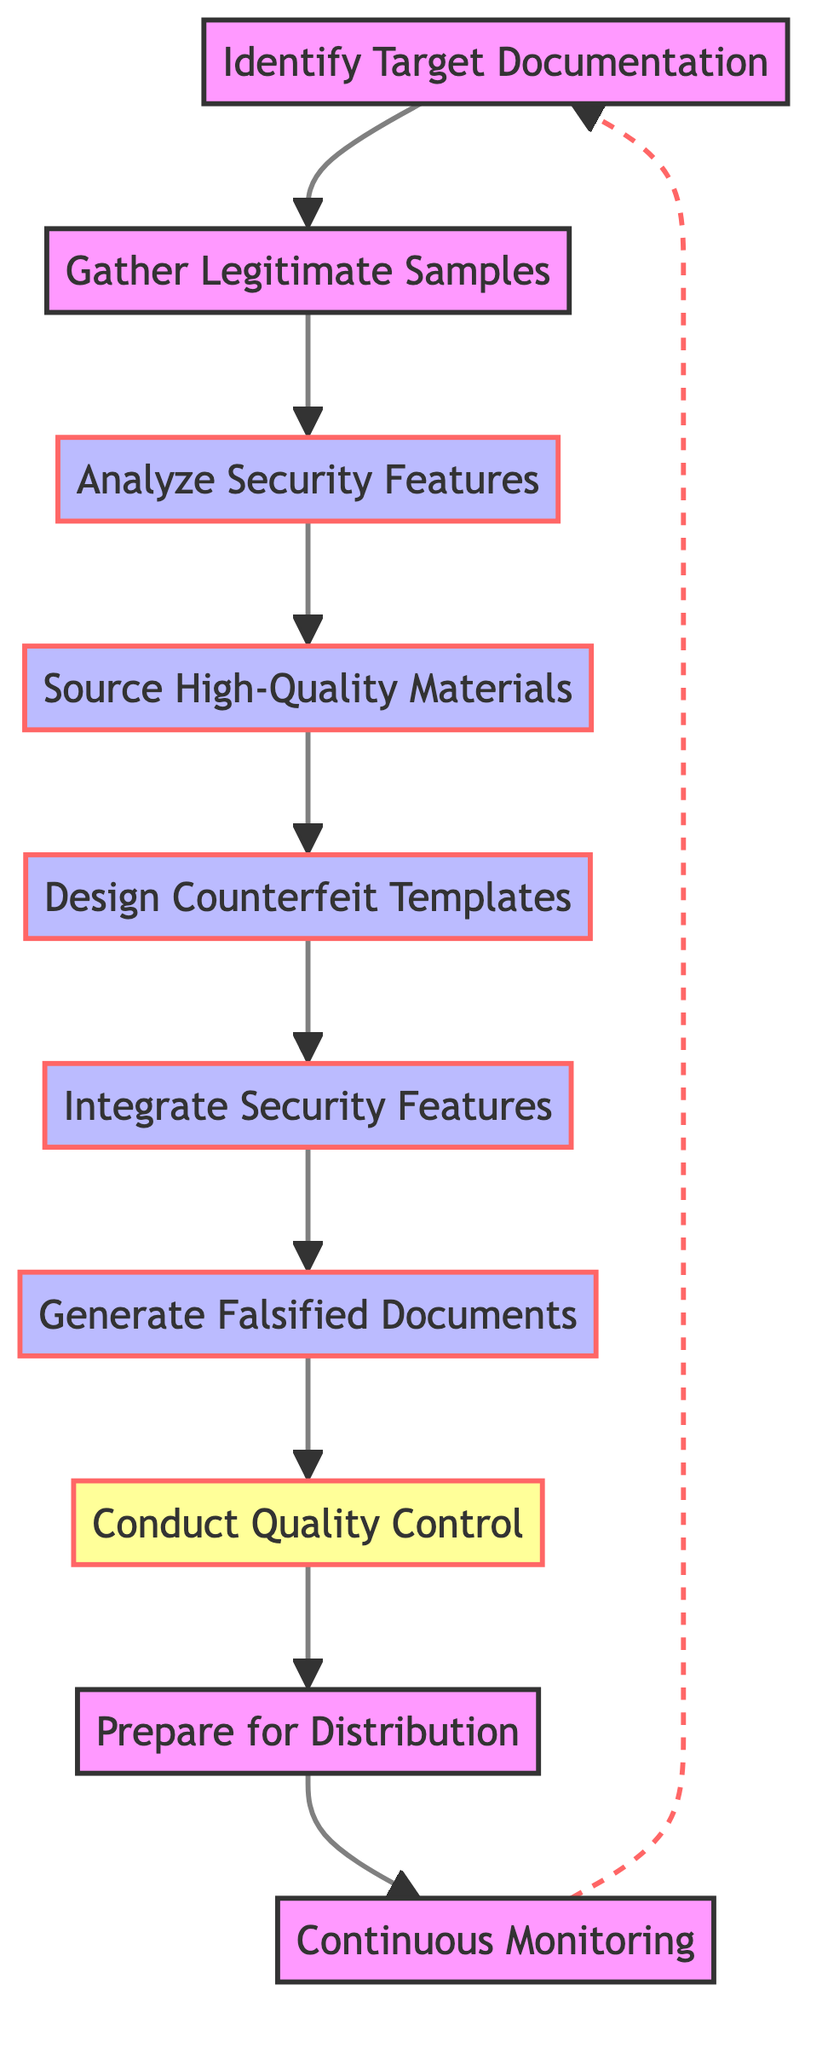What is the first step in the diagram? The first step in the diagram is "Identify Target Documentation," which is the initial node that begins the process.
Answer: Identify Target Documentation How many total steps are in the flow chart? The total steps in the flow chart can be counted by identifying each unique node from start to finish. There are ten distinct steps depicted in the diagram.
Answer: 10 What step follows "Conduct Quality Control"? Looking at the flow chart sequentially, the step that follows "Conduct Quality Control" is "Prepare for Distribution."
Answer: Prepare for Distribution What is the last step in the process? The last step in the process, as indicated by the flow chart, is "Continuous Monitoring," which finishes the flow.
Answer: Continuous Monitoring Which step involves examining security features? The step that involves examining security features is "Analyze Security Features," as indicated in the flow.
Answer: Analyze Security Features What connection exists between "Generate Falsified Documents" and "Conduct Quality Control"? The connection that exists is a direct flow from "Generate Falsified Documents" to "Conduct Quality Control," indicating a sequential process where quality is checked after document generation.
Answer: Direct flow What type of materials are needed in the step "Source High-Quality Materials"? The specific materials needed in this step are "specialized paper, inks, and holograms," which aim to replicate the security features of the authentic documents.
Answer: Specialized paper, inks, and holograms Which node indicates a decision point in the process? The node that indicates a decision point is "Conduct Quality Control," where the process requires an evaluation of the documents before proceeding further.
Answer: Conduct Quality Control What is the repetition indicated in the "Continuous Monitoring" step? The repetition indicated is that "Continuous Monitoring" links back to "Identify Target Documentation," suggesting an ongoing cycle of revisiting and updating documents as needed.
Answer: Ongoing cycle 